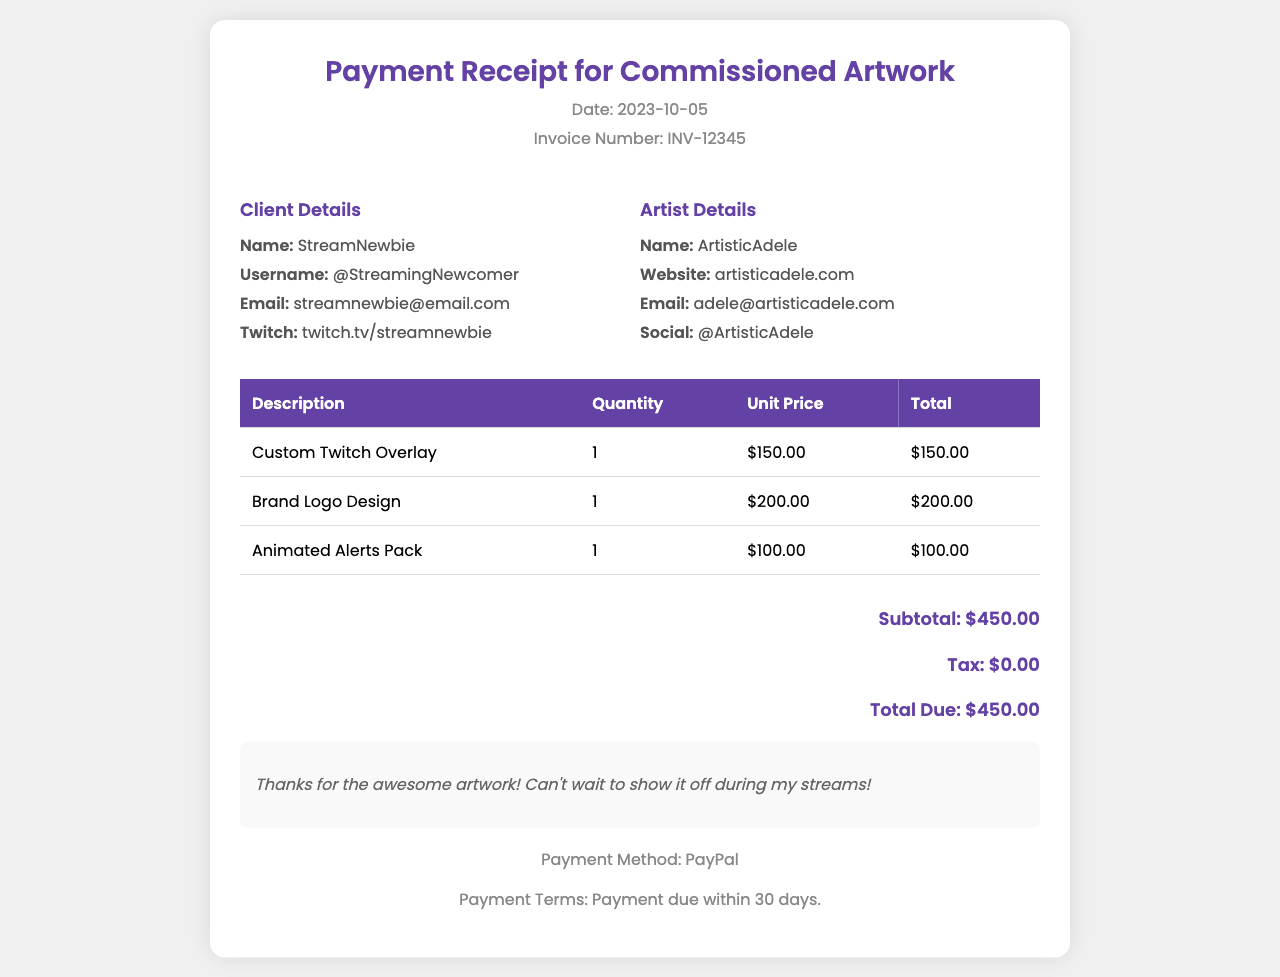What is the invoice number? The invoice number is clearly stated in the header of the document.
Answer: INV-12345 What is the total due amount? The total amount due is calculated from the subtotal and tax included in the invoice.
Answer: $450.00 Who is the artist? The artist's name is listed in the details section under Artist Details.
Answer: ArtisticAdele How much was charged for the Brand Logo Design? The charge for the Brand Logo Design is listed in the table of items provided.
Answer: $200.00 When is the payment due? The payment terms specify when the payment must be made within the document.
Answer: 30 days What is StreamNewbie's Twitch username? The Twitch username is highlighted in the Client Details section of the invoice.
Answer: twitch.tv/streamnewbie What payment method was used? The payment method is mentioned in the payment information section of the document.
Answer: PayPal What is the subtotal amount? The subtotal is specified before tax in the total calculations.
Answer: $450.00 What was the purpose of the invoice? The invoice is for commissioned artwork used for streaming overlays and branding.
Answer: Commissioned Artwork 